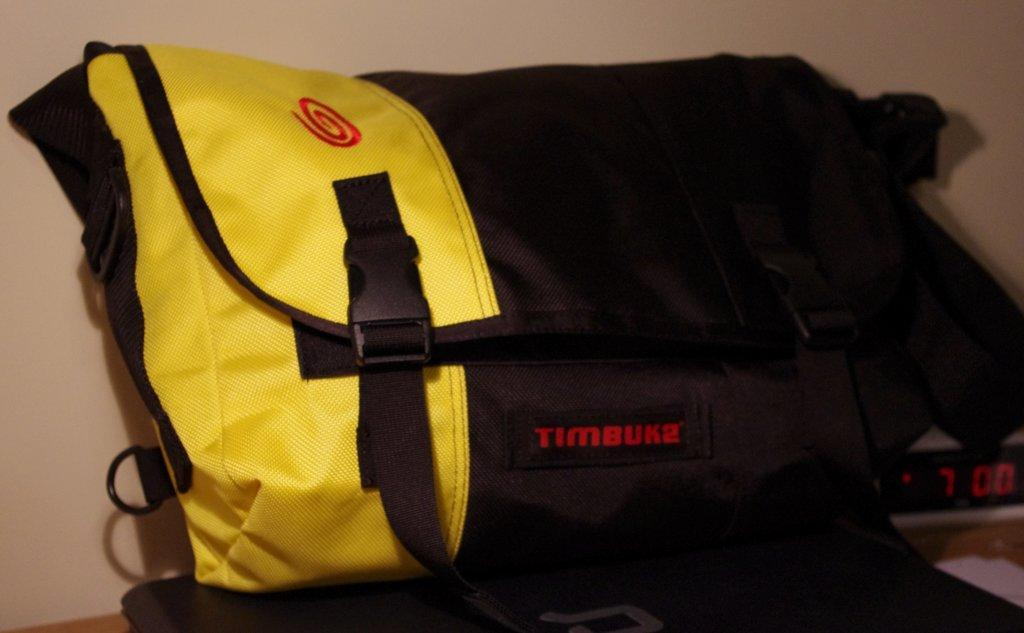What object is present in the image that can be used for carrying items? There is a bag in the image that can be used for carrying items. What colors are used to design the bag? The bag is black and yellow in color. Is there any text or writing on the bag? Yes, there is text on the bag. What type of chalk is being used to write on the bag in the image? There is no chalk present in the image, and no writing is being done on the bag. 